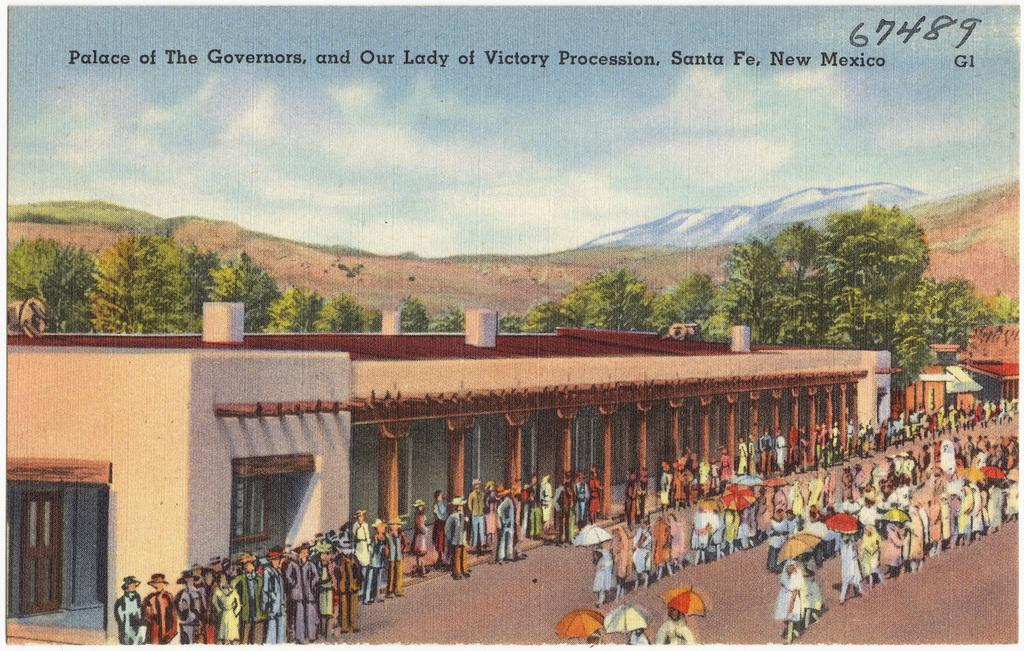What style is the image in? The image is a cartoon. Who or what can be seen in the picture? There is a person in the picture. What structures are present in the image? There is a building in the picture. What type of natural environment is depicted in the image? There are trees in the picture. What part of the natural environment is visible in the sky? The sky is visible in the picture. What geographical feature can be seen in the image? There is a hill visible in the picture. What type of toy can be seen hanging from the tree in the image? There is no toy present in the image, and therefore no such object can be observed hanging from the tree. How many leaves are on the tree in the image? The image is a cartoon, and the trees are not depicted with individual leaves, so it is not possible to determine the number of leaves on the tree. 